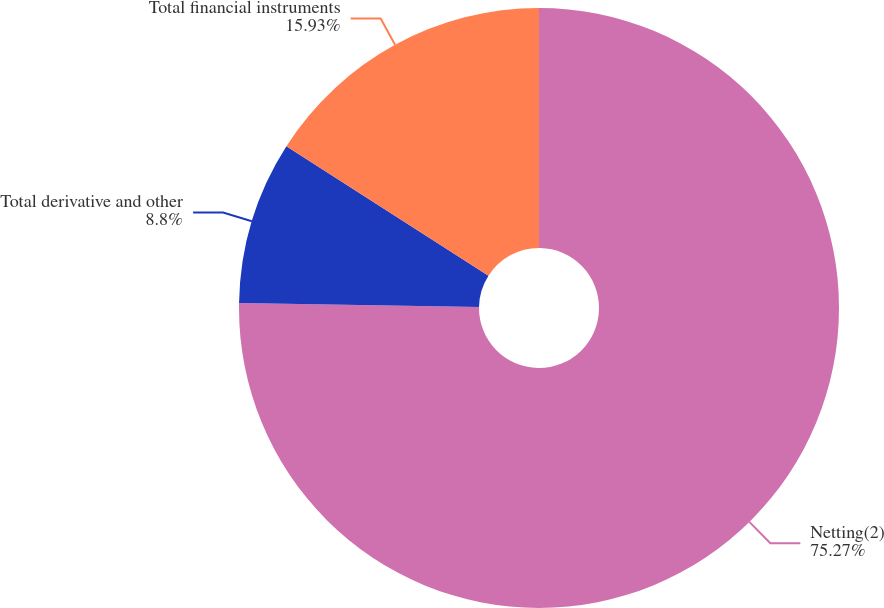Convert chart. <chart><loc_0><loc_0><loc_500><loc_500><pie_chart><fcel>Netting(2)<fcel>Total derivative and other<fcel>Total financial instruments<nl><fcel>75.27%<fcel>8.8%<fcel>15.93%<nl></chart> 